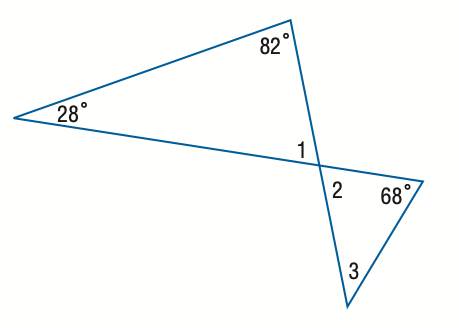Answer the mathemtical geometry problem and directly provide the correct option letter.
Question: Find the measure of \angle 3.
Choices: A: 28 B: 32 C: 38 D: 42 D 